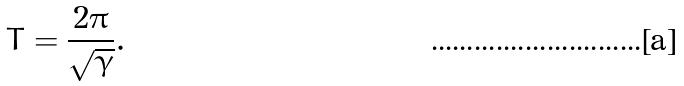<formula> <loc_0><loc_0><loc_500><loc_500>T = \frac { 2 \pi } { \sqrt { \gamma } } .</formula> 